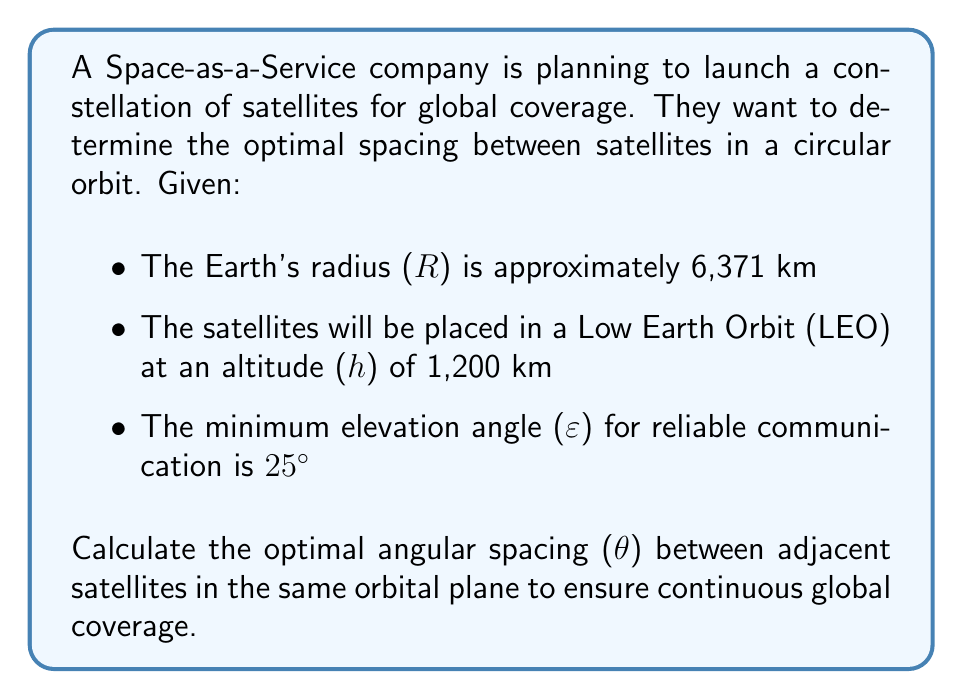Could you help me with this problem? To solve this problem, we need to follow these steps:

1. Calculate the radius of the satellite orbit:
   $$r = R + h = 6,371 \text{ km} + 1,200 \text{ km} = 7,571 \text{ km}$$

2. Determine the maximum Earth central angle (α) that a satellite can cover:
   $$\alpha = \arccos\left(\frac{R}{r} \cos(90^\circ + \varepsilon)\right) - \varepsilon$$
   $$\alpha = \arccos\left(\frac{6,371}{7,571} \cos(115^\circ)\right) - 25^\circ$$
   $$\alpha \approx 34.23^\circ$$

3. Calculate the optimal angular spacing (θ) between adjacent satellites:
   The optimal spacing is twice the maximum Earth central angle:
   $$\theta = 2\alpha$$
   $$\theta = 2 \times 34.23^\circ \approx 68.46^\circ$$

[asy]
import geometry;

real R = 6371;
real h = 1200;
real r = R + h;
real epsilon = 25 * pi / 180;
real alpha = acos((R/r) * cos(pi/2 + epsilon)) - epsilon;
real theta = 2 * alpha;

pair O = (0,0);
draw(circle(O, R), rgb(0,0,1));
draw(circle(O, r), rgb(0.5,0.5,0.5));

pair A = r * dir(0);
pair B = r * dir(theta);

draw(O--A, arrow=Arrow(TeXHead));
draw(O--B, arrow=Arrow(TeXHead));

label("Earth", O, S);
label("R", (R/2,0), S);
label("h", (R+h/2,0), N);
label("θ", (r*cos(theta/2), r*sin(theta/2)), N);

dot("Satellite 1", A, E);
dot("Satellite 2", B, E);

[/asy]

This angular spacing ensures that as one satellite moves out of range, the adjacent satellite comes into view, providing continuous global coverage.
Answer: The optimal angular spacing between adjacent satellites in the same orbital plane is approximately $68.46^\circ$. 